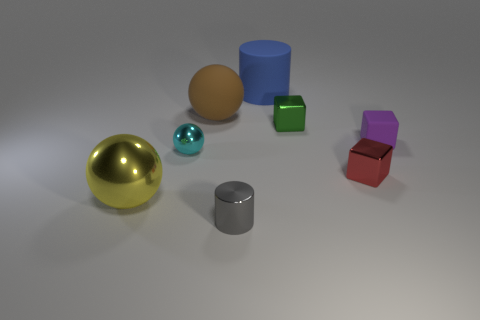Subtract all purple rubber cubes. How many cubes are left? 2 Add 1 tiny red objects. How many objects exist? 9 Subtract 1 balls. How many balls are left? 2 Subtract all cylinders. How many objects are left? 6 Subtract all green balls. Subtract all green cylinders. How many balls are left? 3 Subtract 0 brown cylinders. How many objects are left? 8 Subtract all blue rubber cylinders. Subtract all purple cubes. How many objects are left? 6 Add 2 small rubber blocks. How many small rubber blocks are left? 3 Add 1 purple spheres. How many purple spheres exist? 1 